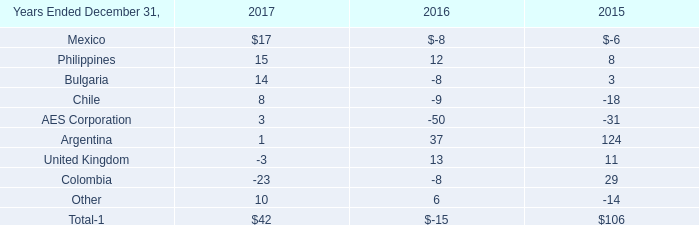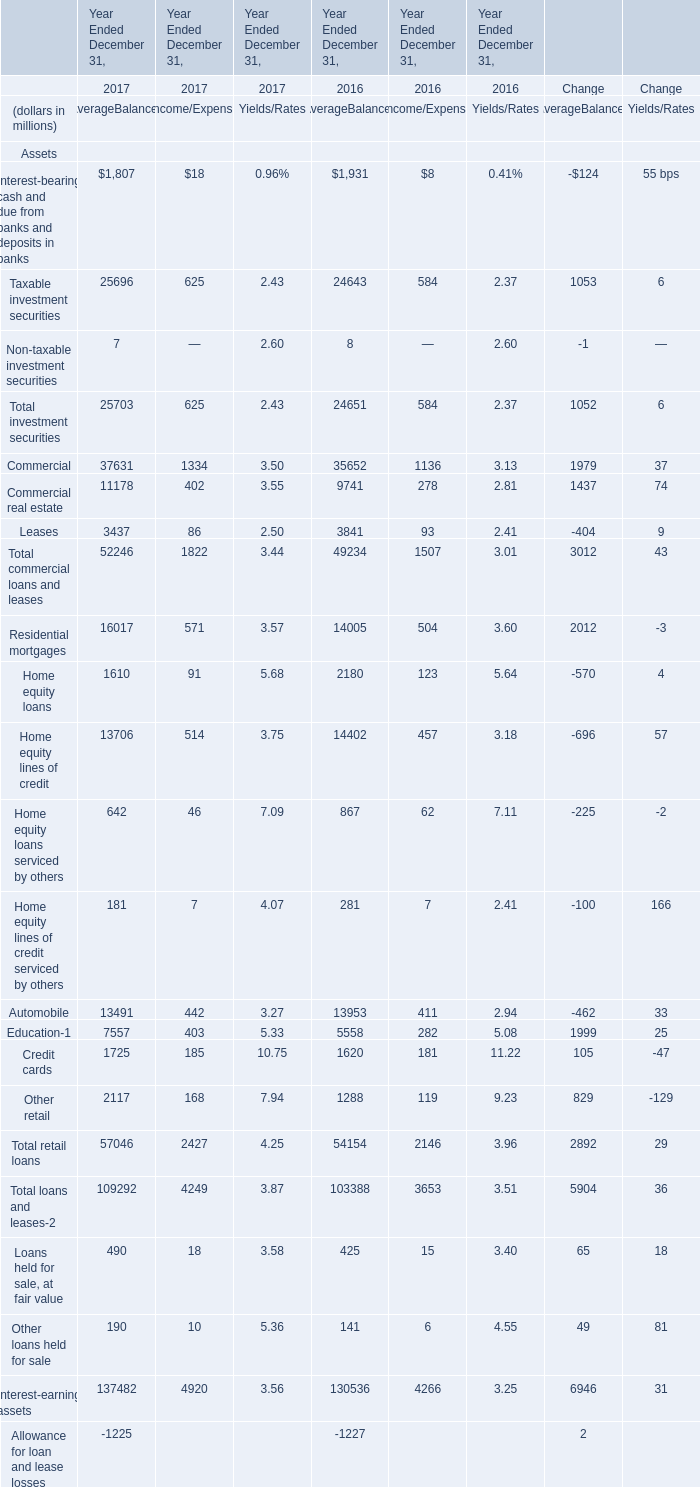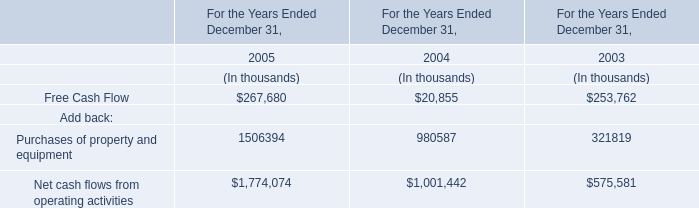What is the growing rate of Commercial for AverageBalances in the year with the most Total investment securities for AverageBalances? 
Computations: ((37631 - 35652) / 35652)
Answer: 0.05551. 